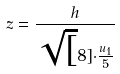Convert formula to latex. <formula><loc_0><loc_0><loc_500><loc_500>z = \frac { h } { \sqrt { [ } 8 ] { \cdot \frac { u _ { 1 } } { 5 } } }</formula> 